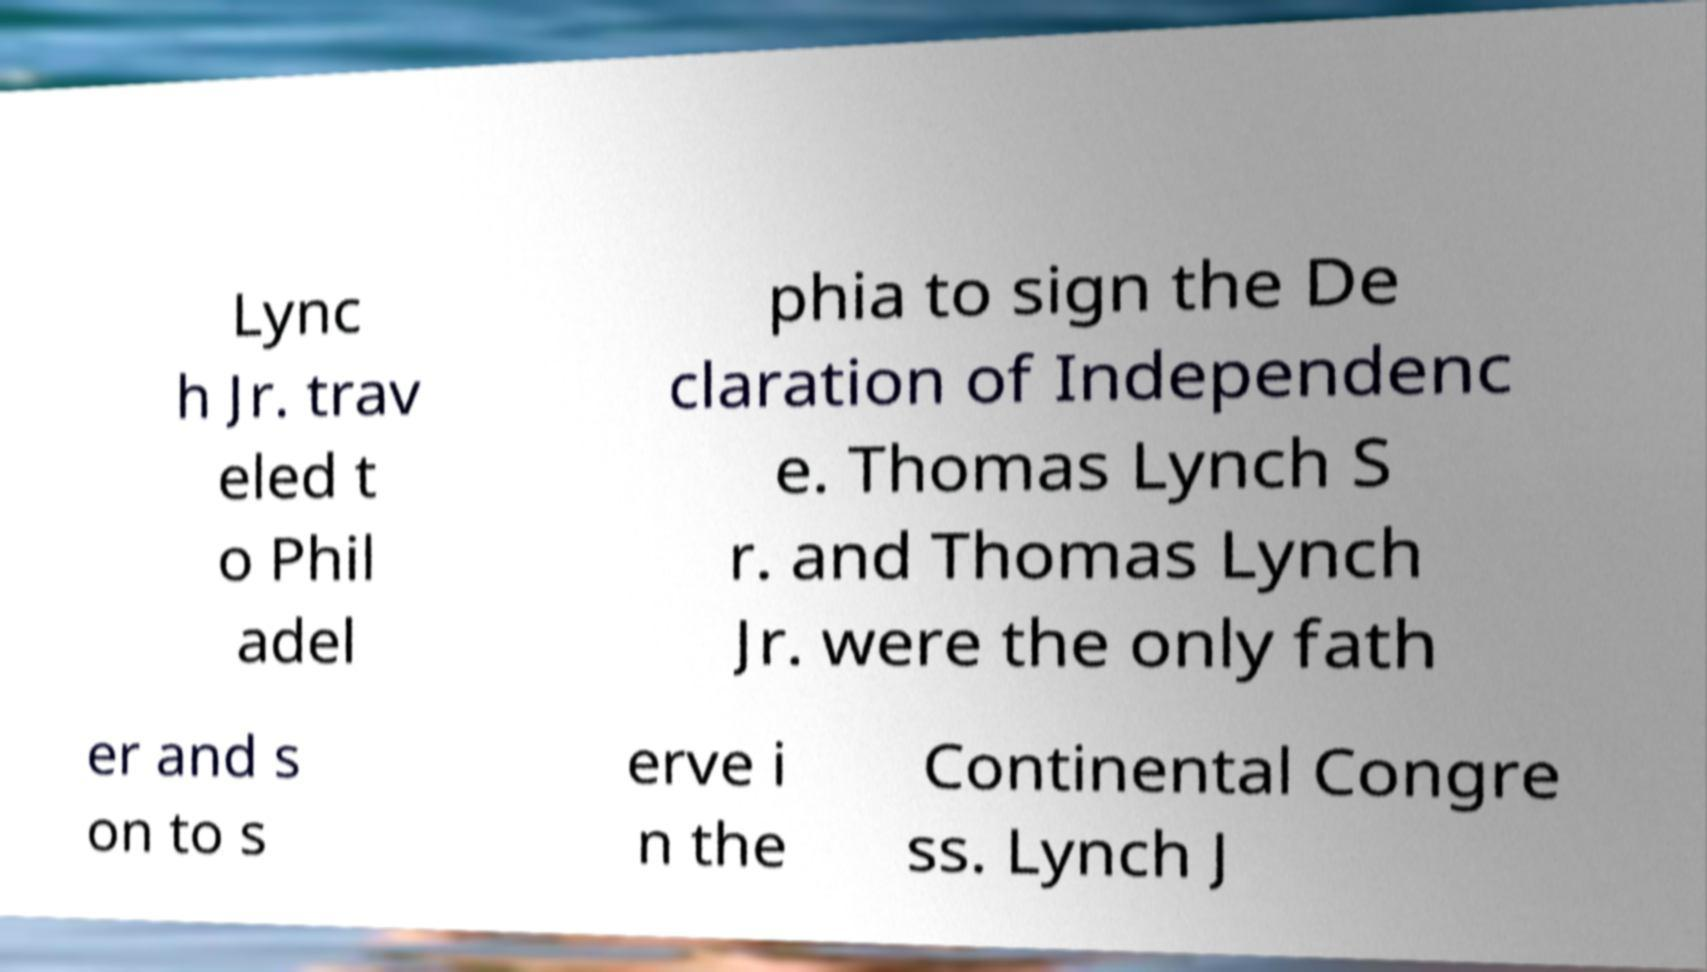There's text embedded in this image that I need extracted. Can you transcribe it verbatim? Lync h Jr. trav eled t o Phil adel phia to sign the De claration of Independenc e. Thomas Lynch S r. and Thomas Lynch Jr. were the only fath er and s on to s erve i n the Continental Congre ss. Lynch J 